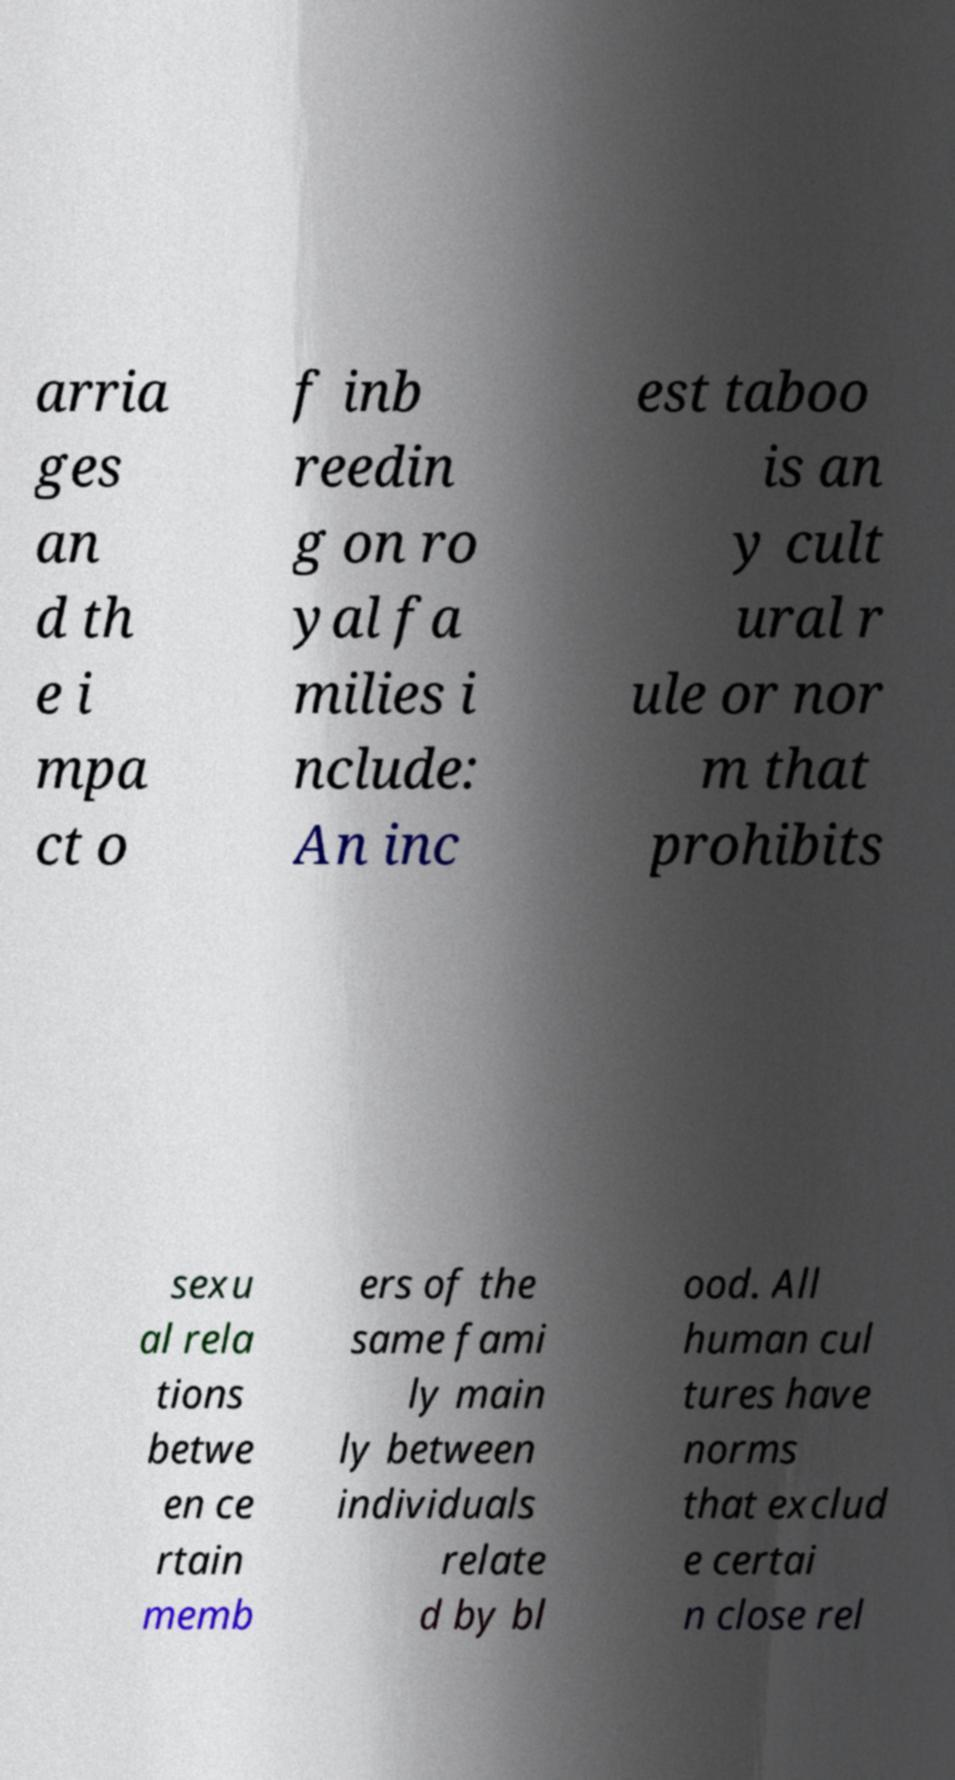Please read and relay the text visible in this image. What does it say? arria ges an d th e i mpa ct o f inb reedin g on ro yal fa milies i nclude: An inc est taboo is an y cult ural r ule or nor m that prohibits sexu al rela tions betwe en ce rtain memb ers of the same fami ly main ly between individuals relate d by bl ood. All human cul tures have norms that exclud e certai n close rel 